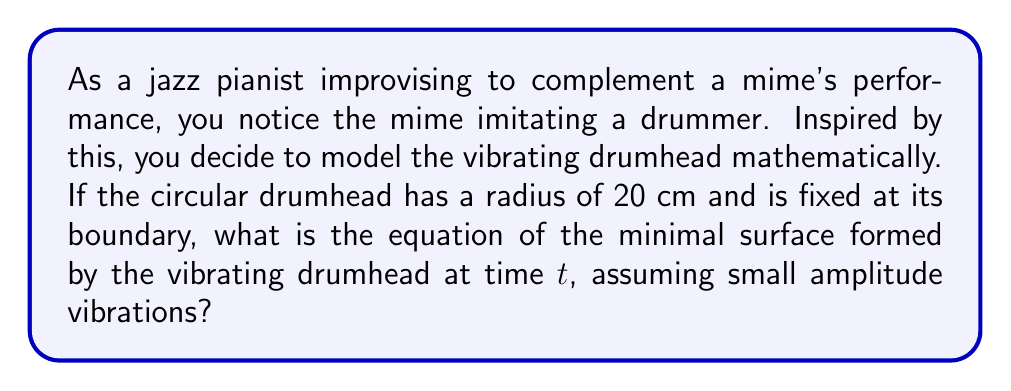Give your solution to this math problem. To solve this problem, we'll follow these steps:

1) The minimal surface formed by a vibrating drumhead can be described by the wave equation in polar coordinates:

   $$\frac{\partial^2 u}{\partial t^2} = c^2 \left(\frac{\partial^2 u}{\partial r^2} + \frac{1}{r}\frac{\partial u}{\partial r} + \frac{1}{r^2}\frac{\partial^2 u}{\partial \theta^2}\right)$$

   where $u(r,\theta,t)$ is the displacement of the drumhead at position $(r,\theta)$ and time $t$, and $c$ is the wave speed.

2) For a circular drumhead with fixed boundary, we can assume radial symmetry, eliminating the $\theta$ dependence:

   $$\frac{\partial^2 u}{\partial t^2} = c^2 \left(\frac{\partial^2 u}{\partial r^2} + \frac{1}{r}\frac{\partial u}{\partial r}\right)$$

3) The solution to this equation that satisfies the boundary conditions (fixed at $r=R$, where $R$ is the radius) is:

   $$u(r,t) = AJ_0(\alpha r)\cos(\omega t)$$

   where $J_0$ is the Bessel function of the first kind of order zero, $A$ is the amplitude, $\alpha$ is a constant, and $\omega$ is the angular frequency.

4) The boundary condition $u(R,t) = 0$ requires that $\alpha R$ be a zero of $J_0$. The smallest such zero is approximately 2.4048.

5) For our drumhead with radius $R = 20$ cm:

   $$\alpha = \frac{2.4048}{R} = \frac{2.4048}{20} = 0.12024 \text{ cm}^{-1}$$

6) The angular frequency $\omega$ is related to $\alpha$ by $\omega = c\alpha$, but we don't need to specify $c$ or $\omega$ for the minimal surface equation.

Therefore, the equation of the minimal surface formed by the vibrating drumhead is:

$$u(r,t) = AJ_0(0.12024r)\cos(\omega t)$$

where $A$ is the maximum amplitude of the vibration (which should be small for the minimal surface approximation to hold).
Answer: $u(r,t) = AJ_0(0.12024r)\cos(\omega t)$ 